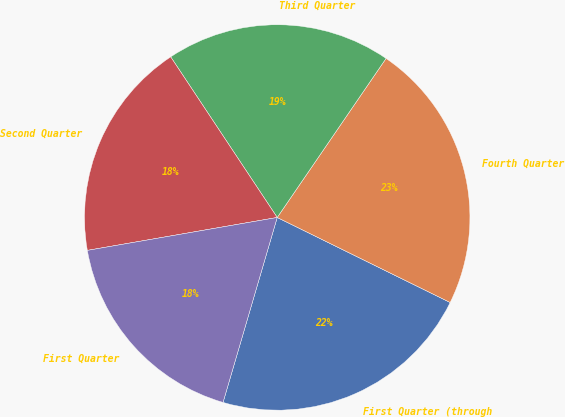Convert chart to OTSL. <chart><loc_0><loc_0><loc_500><loc_500><pie_chart><fcel>First Quarter (through<fcel>Fourth Quarter<fcel>Third Quarter<fcel>Second Quarter<fcel>First Quarter<nl><fcel>22.26%<fcel>22.72%<fcel>18.87%<fcel>18.41%<fcel>17.73%<nl></chart> 